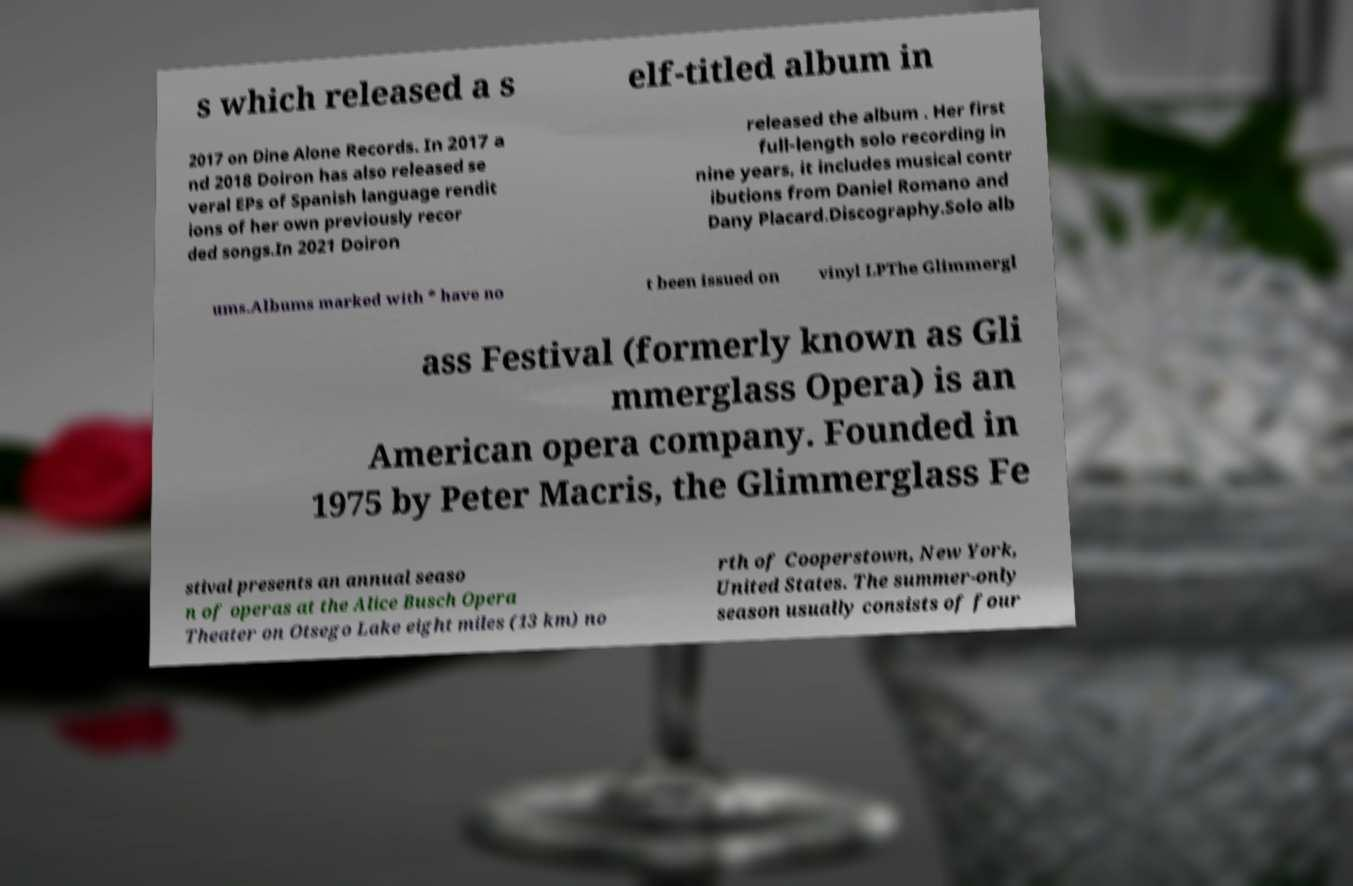Can you accurately transcribe the text from the provided image for me? s which released a s elf-titled album in 2017 on Dine Alone Records. In 2017 a nd 2018 Doiron has also released se veral EPs of Spanish language rendit ions of her own previously recor ded songs.In 2021 Doiron released the album . Her first full-length solo recording in nine years, it includes musical contr ibutions from Daniel Romano and Dany Placard.Discography.Solo alb ums.Albums marked with * have no t been issued on vinyl LPThe Glimmergl ass Festival (formerly known as Gli mmerglass Opera) is an American opera company. Founded in 1975 by Peter Macris, the Glimmerglass Fe stival presents an annual seaso n of operas at the Alice Busch Opera Theater on Otsego Lake eight miles (13 km) no rth of Cooperstown, New York, United States. The summer-only season usually consists of four 